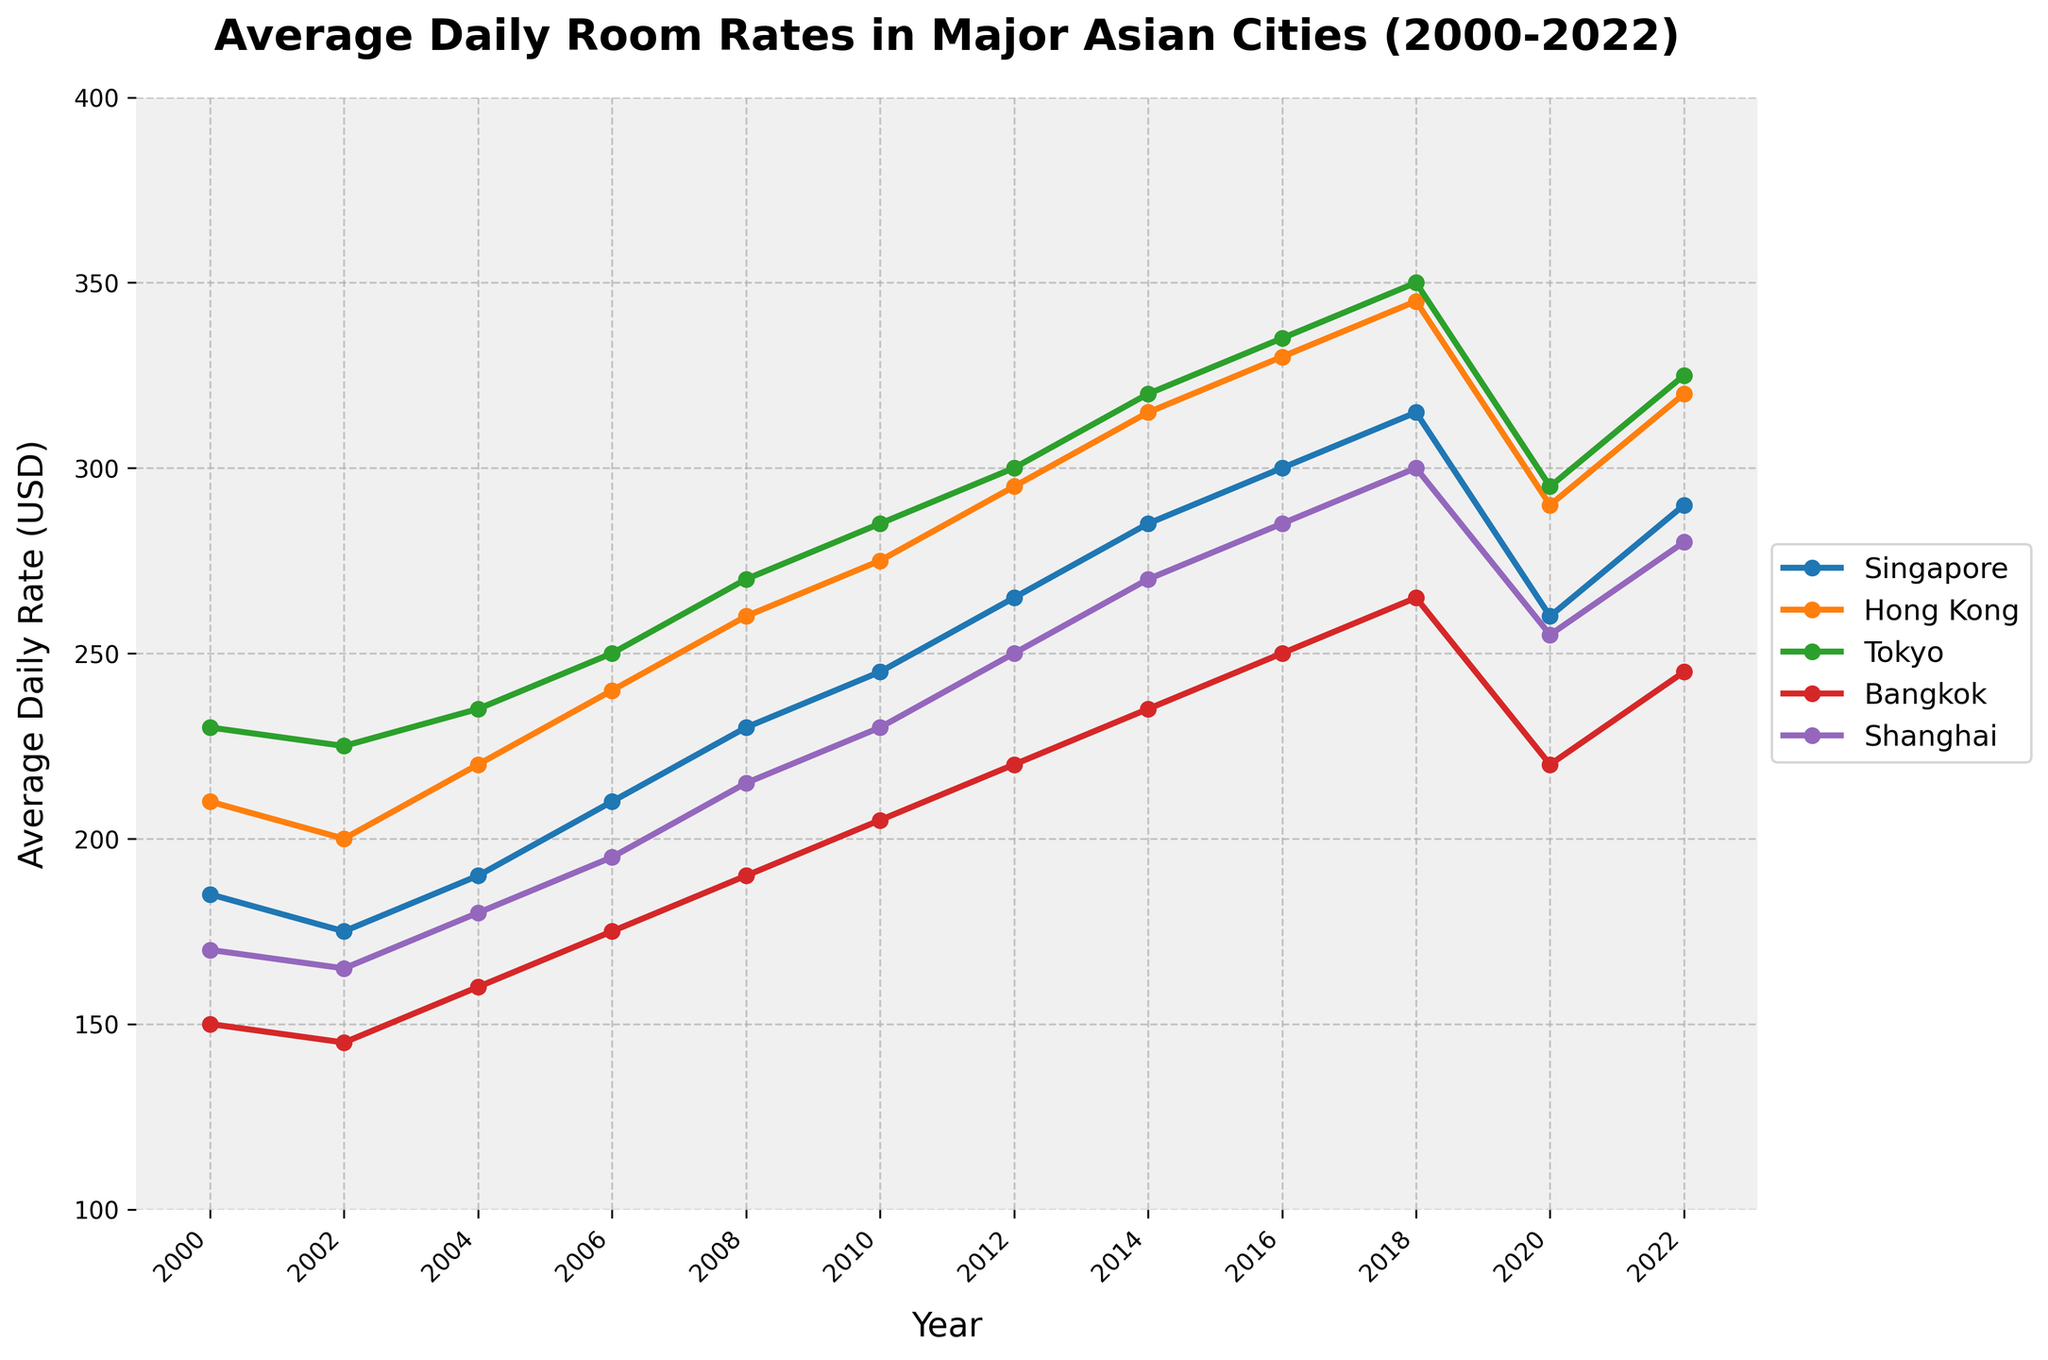What's the average room rate for Tokyo across all years? To find the average room rate for Tokyo, sum up all the values for Tokyo and divide by the number of years. These values are: 230, 225, 235, 250, 270, 285, 300, 320, 335, 350, 295, 325. Their sum is 3420. There are 12 years, so the average is 3420 / 12 = 285.
Answer: 285 Which city had the highest average room rate in 2018? Look at the data points for 2018. Compare values for Singapore (315), Hong Kong (345), Tokyo (350), Bangkok (265), and Shanghai (300). The highest value is for Tokyo.
Answer: Tokyo In which year did Singapore see the biggest drop in average room rates compared to the previous year? Compare the yearly differences: 2002-2000: -10, 2004-2002: 15, 2006-2004: 20, 2008-2006: 20, 2010-2008: 15, 2012-2010: 20, 2014-2012: 20, 2016-2014: 15, 2018-2016: 15, 2020-2018: -55, 2022-2020: 30. The largest drop is in 2020.
Answer: 2020 What is the total increase in room rates for Bangkok from 2000 to 2022? Subtract the value in 2000 from the value in 2022: 245 - 150 = 95.
Answer: 95 Between Hong Kong and Shanghai, which city had higher room rates in 2010? Compare the values for both cities in 2010: Hong Kong is 275 and Shanghai is 230. Hong Kong has higher rates.
Answer: Hong Kong How much did the average room rates for Shanghai increase from 2006 to 2014? Subtract the value in 2006 from the 2014 value: 270 - 195 = 75.
Answer: 75 Which city experienced a decrease in average room rates from 2018 to 2020, and by how much? Compare 2018 vs 2020 for each city: Singapore (315 to 260: -55), Hong Kong (345 to 290: -55), Tokyo (350 to 295: -55), Bangkok (265 to 220: -45), Shanghai (300 to 255: -45). All cities experienced a decrease.
Answer: All cities, 45 to 55 Which city had the least variation in room rates over the entire period? Calculate the range (max-min) for each city: 
- Singapore: 300 - 175 = 125
- Hong Kong: 345 - 200 = 145
- Tokyo: 350 - 225 = 125
- Bangkok: 265 - 145 = 120 
- Shanghai: 300 - 165 = 135 
Bangkok has the least variation.
Answer: Bangkok 